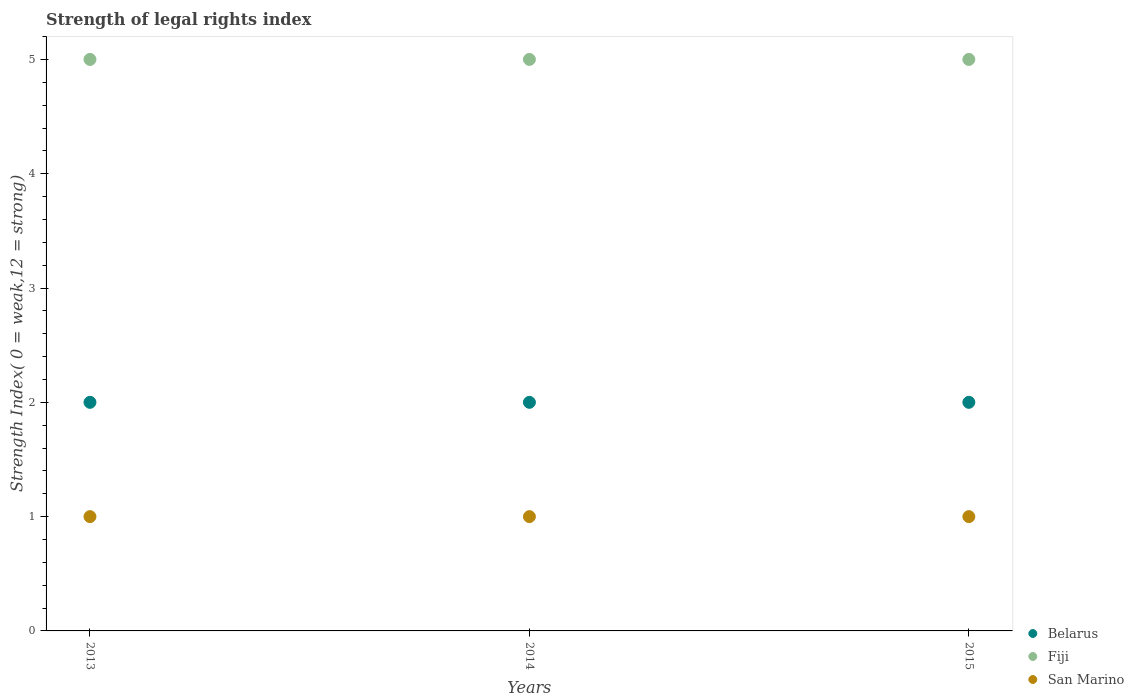How many different coloured dotlines are there?
Your response must be concise. 3. What is the strength index in Belarus in 2014?
Provide a succinct answer. 2. Across all years, what is the maximum strength index in San Marino?
Give a very brief answer. 1. Across all years, what is the minimum strength index in Fiji?
Ensure brevity in your answer.  5. In which year was the strength index in Belarus maximum?
Keep it short and to the point. 2013. What is the total strength index in Fiji in the graph?
Your answer should be very brief. 15. What is the difference between the strength index in Fiji in 2013 and that in 2015?
Provide a short and direct response. 0. What is the difference between the strength index in Belarus in 2015 and the strength index in San Marino in 2014?
Your response must be concise. 1. What is the average strength index in San Marino per year?
Your answer should be very brief. 1. In the year 2014, what is the difference between the strength index in Fiji and strength index in San Marino?
Make the answer very short. 4. What is the ratio of the strength index in San Marino in 2013 to that in 2015?
Give a very brief answer. 1. Is the difference between the strength index in Fiji in 2013 and 2015 greater than the difference between the strength index in San Marino in 2013 and 2015?
Your answer should be very brief. No. What is the difference between the highest and the second highest strength index in Belarus?
Offer a very short reply. 0. What is the difference between the highest and the lowest strength index in Belarus?
Ensure brevity in your answer.  0. In how many years, is the strength index in Fiji greater than the average strength index in Fiji taken over all years?
Ensure brevity in your answer.  0. Is it the case that in every year, the sum of the strength index in Fiji and strength index in San Marino  is greater than the strength index in Belarus?
Your response must be concise. Yes. What is the difference between two consecutive major ticks on the Y-axis?
Provide a short and direct response. 1. Are the values on the major ticks of Y-axis written in scientific E-notation?
Your answer should be compact. No. Does the graph contain any zero values?
Provide a succinct answer. No. Does the graph contain grids?
Your answer should be compact. No. Where does the legend appear in the graph?
Make the answer very short. Bottom right. What is the title of the graph?
Offer a very short reply. Strength of legal rights index. Does "St. Lucia" appear as one of the legend labels in the graph?
Ensure brevity in your answer.  No. What is the label or title of the X-axis?
Make the answer very short. Years. What is the label or title of the Y-axis?
Your answer should be compact. Strength Index( 0 = weak,12 = strong). What is the Strength Index( 0 = weak,12 = strong) in Belarus in 2013?
Your answer should be very brief. 2. What is the Strength Index( 0 = weak,12 = strong) of Fiji in 2014?
Make the answer very short. 5. What is the Strength Index( 0 = weak,12 = strong) of Fiji in 2015?
Give a very brief answer. 5. What is the Strength Index( 0 = weak,12 = strong) of San Marino in 2015?
Provide a short and direct response. 1. Across all years, what is the maximum Strength Index( 0 = weak,12 = strong) of Belarus?
Your answer should be compact. 2. Across all years, what is the maximum Strength Index( 0 = weak,12 = strong) in Fiji?
Ensure brevity in your answer.  5. Across all years, what is the maximum Strength Index( 0 = weak,12 = strong) in San Marino?
Give a very brief answer. 1. Across all years, what is the minimum Strength Index( 0 = weak,12 = strong) in Fiji?
Your answer should be compact. 5. What is the total Strength Index( 0 = weak,12 = strong) of San Marino in the graph?
Offer a very short reply. 3. What is the difference between the Strength Index( 0 = weak,12 = strong) of Belarus in 2013 and that in 2014?
Keep it short and to the point. 0. What is the difference between the Strength Index( 0 = weak,12 = strong) in Belarus in 2013 and that in 2015?
Your answer should be very brief. 0. What is the difference between the Strength Index( 0 = weak,12 = strong) of Fiji in 2013 and that in 2015?
Ensure brevity in your answer.  0. What is the difference between the Strength Index( 0 = weak,12 = strong) in Belarus in 2013 and the Strength Index( 0 = weak,12 = strong) in Fiji in 2014?
Your response must be concise. -3. What is the difference between the Strength Index( 0 = weak,12 = strong) in Belarus in 2013 and the Strength Index( 0 = weak,12 = strong) in San Marino in 2014?
Make the answer very short. 1. What is the difference between the Strength Index( 0 = weak,12 = strong) in Belarus in 2014 and the Strength Index( 0 = weak,12 = strong) in San Marino in 2015?
Provide a succinct answer. 1. What is the average Strength Index( 0 = weak,12 = strong) in Fiji per year?
Offer a very short reply. 5. In the year 2013, what is the difference between the Strength Index( 0 = weak,12 = strong) in Belarus and Strength Index( 0 = weak,12 = strong) in San Marino?
Give a very brief answer. 1. In the year 2013, what is the difference between the Strength Index( 0 = weak,12 = strong) in Fiji and Strength Index( 0 = weak,12 = strong) in San Marino?
Your answer should be very brief. 4. In the year 2014, what is the difference between the Strength Index( 0 = weak,12 = strong) of Belarus and Strength Index( 0 = weak,12 = strong) of Fiji?
Offer a very short reply. -3. In the year 2015, what is the difference between the Strength Index( 0 = weak,12 = strong) in Belarus and Strength Index( 0 = weak,12 = strong) in Fiji?
Your answer should be compact. -3. In the year 2015, what is the difference between the Strength Index( 0 = weak,12 = strong) in Belarus and Strength Index( 0 = weak,12 = strong) in San Marino?
Keep it short and to the point. 1. What is the ratio of the Strength Index( 0 = weak,12 = strong) of Belarus in 2013 to that in 2015?
Ensure brevity in your answer.  1. What is the ratio of the Strength Index( 0 = weak,12 = strong) of Fiji in 2013 to that in 2015?
Provide a succinct answer. 1. What is the ratio of the Strength Index( 0 = weak,12 = strong) in Belarus in 2014 to that in 2015?
Provide a short and direct response. 1. What is the ratio of the Strength Index( 0 = weak,12 = strong) of San Marino in 2014 to that in 2015?
Offer a very short reply. 1. What is the difference between the highest and the second highest Strength Index( 0 = weak,12 = strong) of Belarus?
Give a very brief answer. 0. What is the difference between the highest and the second highest Strength Index( 0 = weak,12 = strong) of Fiji?
Your answer should be very brief. 0. What is the difference between the highest and the lowest Strength Index( 0 = weak,12 = strong) of Belarus?
Offer a terse response. 0. What is the difference between the highest and the lowest Strength Index( 0 = weak,12 = strong) of Fiji?
Make the answer very short. 0. 